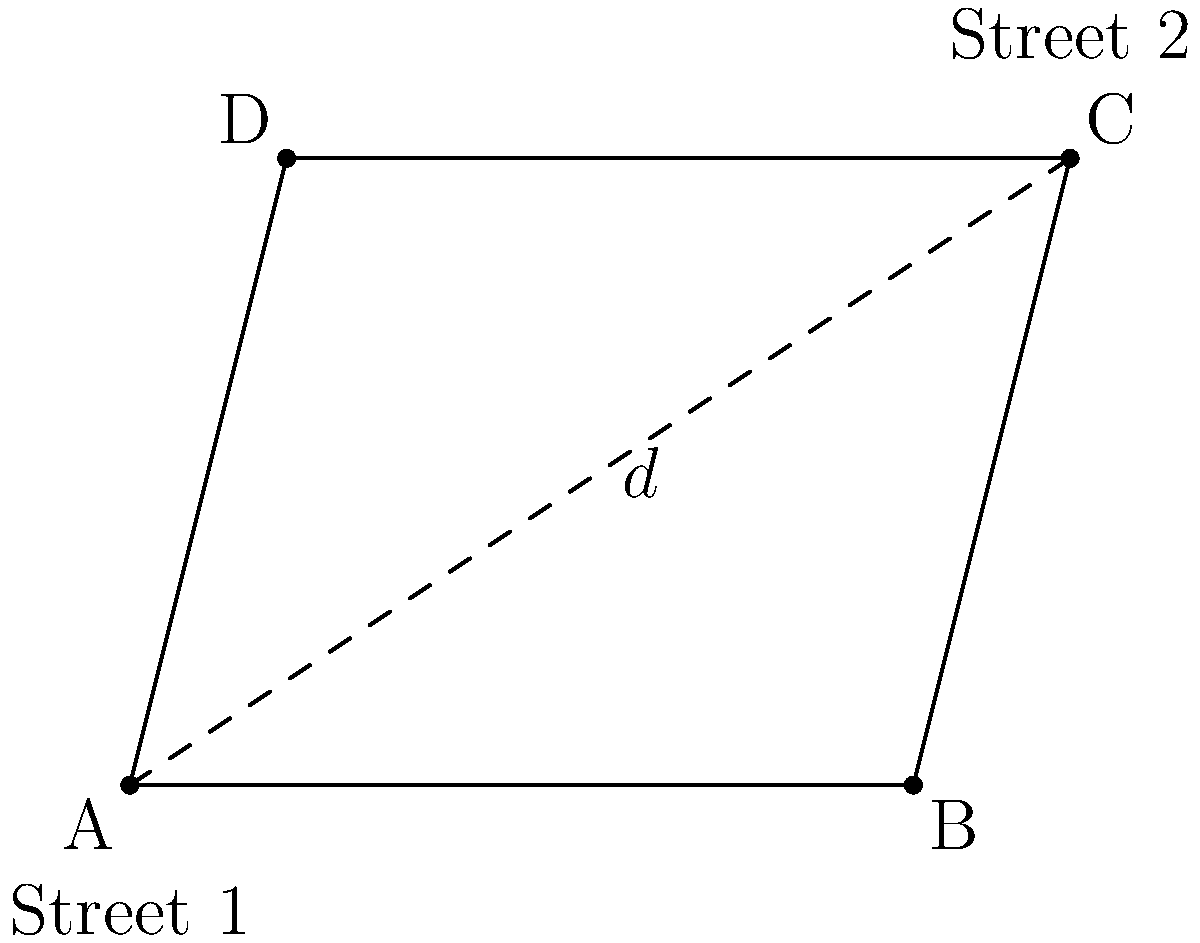In a city planning scenario, two non-parallel streets are represented by lines AB and CD in the diagram. What is the minimum distance $d$ between these streets if AB is 100 units long and the perpendicular distance from point C to line AB is 80 units? To find the minimum distance between two non-parallel lines, we need to determine the length of the perpendicular line segment connecting them. Let's approach this step-by-step:

1) The perpendicular line segment representing the minimum distance will form a right triangle with the two streets.

2) We are given that AB = 100 units and the height of the triangle (perpendicular from C to AB) is 80 units.

3) To find the minimum distance, we need to find the sine of the angle between the streets and use it in the equation:

   $d = h \cdot \sin(\theta)$

   where $h$ is the given height (80 units) and $\theta$ is the angle between the streets.

4) To find $\sin(\theta)$, we can use the right triangle formed by the height and AB:

   $\sin(\theta) = \frac{\text{opposite}}{\text{hypotenuse}} = \frac{20}{100} = 0.2$

5) Now we can calculate the minimum distance:

   $d = 80 \cdot 0.2 = 16$ units

Therefore, the minimum distance between the two streets is 16 units.

This problem demonstrates the application of trigonometry in urban planning and real estate law, which could be relevant in cases involving property boundaries or zoning regulations.
Answer: 16 units 